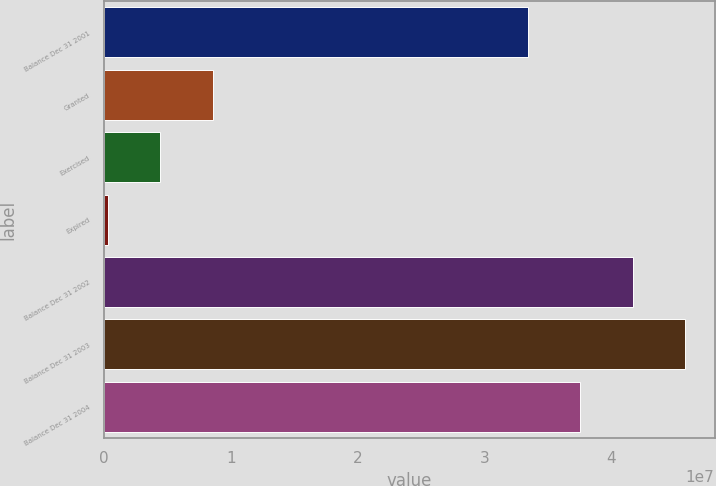Convert chart to OTSL. <chart><loc_0><loc_0><loc_500><loc_500><bar_chart><fcel>Balance Dec 31 2001<fcel>Granted<fcel>Exercised<fcel>Expired<fcel>Balance Dec 31 2002<fcel>Balance Dec 31 2003<fcel>Balance Dec 31 2004<nl><fcel>3.34135e+07<fcel>8.57264e+06<fcel>4.42999e+06<fcel>287341<fcel>4.16988e+07<fcel>4.58415e+07<fcel>3.75562e+07<nl></chart> 